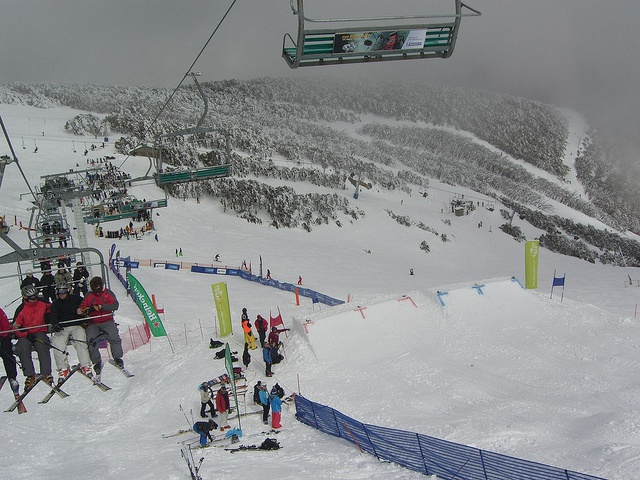Describe the objects in this image and their specific colors. I can see people in gray, darkgray, black, and blue tones, people in gray, black, maroon, and brown tones, people in gray, black, and darkgray tones, people in gray, black, and maroon tones, and skis in gray, darkgray, lightgray, and black tones in this image. 